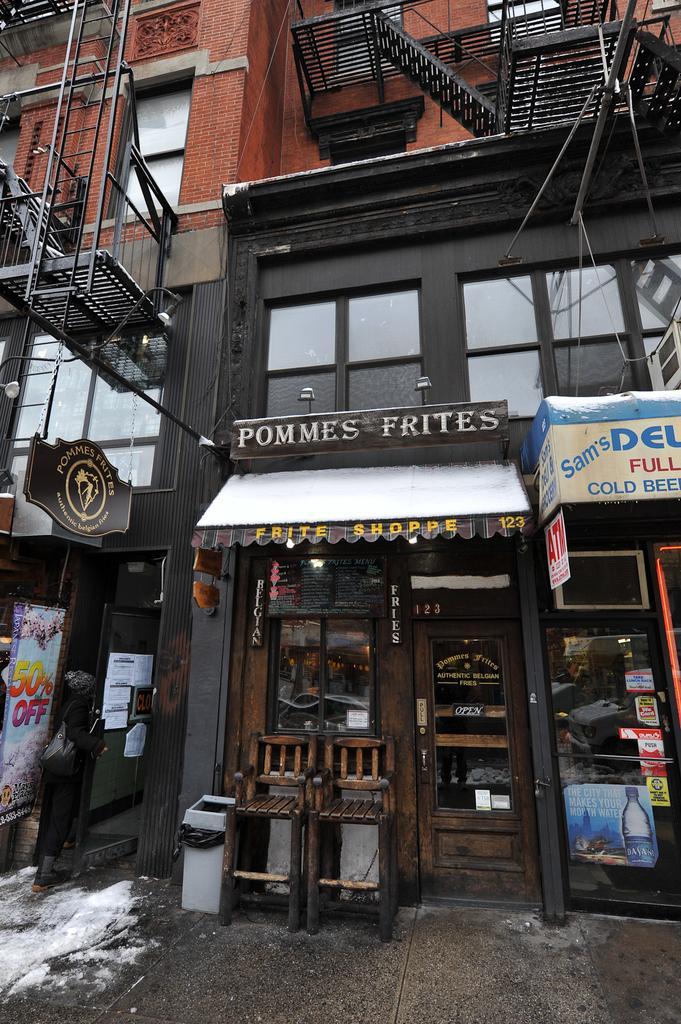In one or two sentences, can you explain what this image depicts? In this image we can see a building, here is the window glass, here is the door, here is the chair on the ground, here is the staircase, here is the wall. 